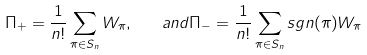Convert formula to latex. <formula><loc_0><loc_0><loc_500><loc_500>\Pi _ { + } = \frac { 1 } { n ! } \sum _ { \pi \in S _ { n } } { W _ { \pi } } , \quad a n d \Pi _ { - } = \frac { 1 } { n ! } \sum _ { \pi \in S _ { n } } { s g n ( \pi ) W _ { \pi } }</formula> 